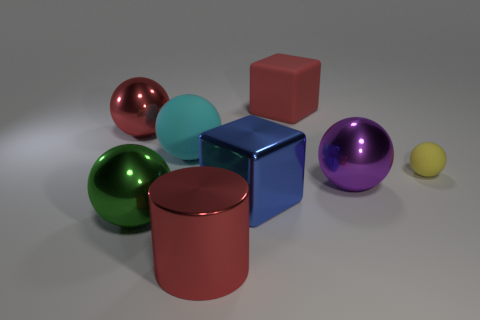Subtract all yellow spheres. How many spheres are left? 4 Subtract 2 balls. How many balls are left? 3 Subtract all cyan spheres. How many spheres are left? 4 Add 1 large brown metallic things. How many objects exist? 9 Subtract all brown balls. Subtract all blue cubes. How many balls are left? 5 Add 4 yellow rubber things. How many yellow rubber things exist? 5 Subtract 0 purple cubes. How many objects are left? 8 Subtract all spheres. How many objects are left? 3 Subtract all big metallic things. Subtract all red spheres. How many objects are left? 2 Add 6 purple shiny balls. How many purple shiny balls are left? 7 